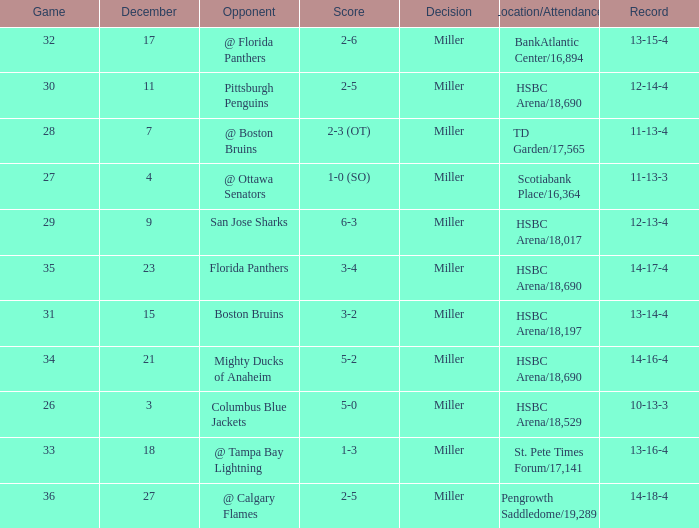Name the december for record 14-17-4 23.0. Would you be able to parse every entry in this table? {'header': ['Game', 'December', 'Opponent', 'Score', 'Decision', 'Location/Attendance', 'Record'], 'rows': [['32', '17', '@ Florida Panthers', '2-6', 'Miller', 'BankAtlantic Center/16,894', '13-15-4'], ['30', '11', 'Pittsburgh Penguins', '2-5', 'Miller', 'HSBC Arena/18,690', '12-14-4'], ['28', '7', '@ Boston Bruins', '2-3 (OT)', 'Miller', 'TD Garden/17,565', '11-13-4'], ['27', '4', '@ Ottawa Senators', '1-0 (SO)', 'Miller', 'Scotiabank Place/16,364', '11-13-3'], ['29', '9', 'San Jose Sharks', '6-3', 'Miller', 'HSBC Arena/18,017', '12-13-4'], ['35', '23', 'Florida Panthers', '3-4', 'Miller', 'HSBC Arena/18,690', '14-17-4'], ['31', '15', 'Boston Bruins', '3-2', 'Miller', 'HSBC Arena/18,197', '13-14-4'], ['34', '21', 'Mighty Ducks of Anaheim', '5-2', 'Miller', 'HSBC Arena/18,690', '14-16-4'], ['26', '3', 'Columbus Blue Jackets', '5-0', 'Miller', 'HSBC Arena/18,529', '10-13-3'], ['33', '18', '@ Tampa Bay Lightning', '1-3', 'Miller', 'St. Pete Times Forum/17,141', '13-16-4'], ['36', '27', '@ Calgary Flames', '2-5', 'Miller', 'Pengrowth Saddledome/19,289', '14-18-4']]} 